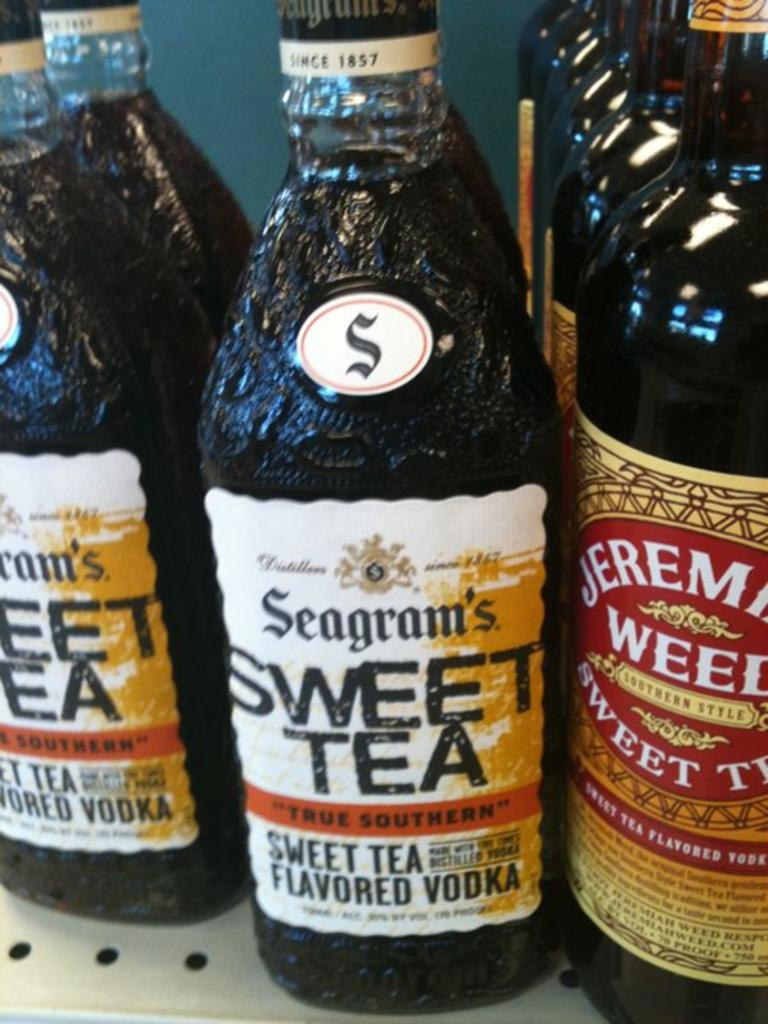What objects are present in the image? There are multiple bottles in the image. What type of ticket is visible in the image? There is no ticket present in the image; it only contains multiple bottles. Can you hear thunder in the image? There is no sound in the image, so it is impossible to hear thunder or any other noise. 